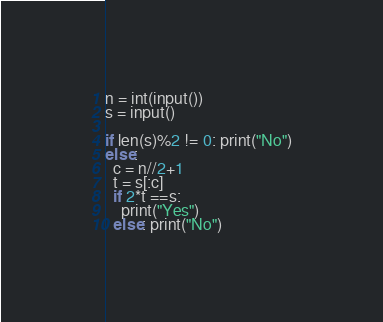<code> <loc_0><loc_0><loc_500><loc_500><_Python_>n = int(input())
s = input()

if len(s)%2 != 0: print("No")
else:
  c = n//2+1
  t = s[:c]
  if 2*t ==s:
    print("Yes")
  else: print("No")</code> 